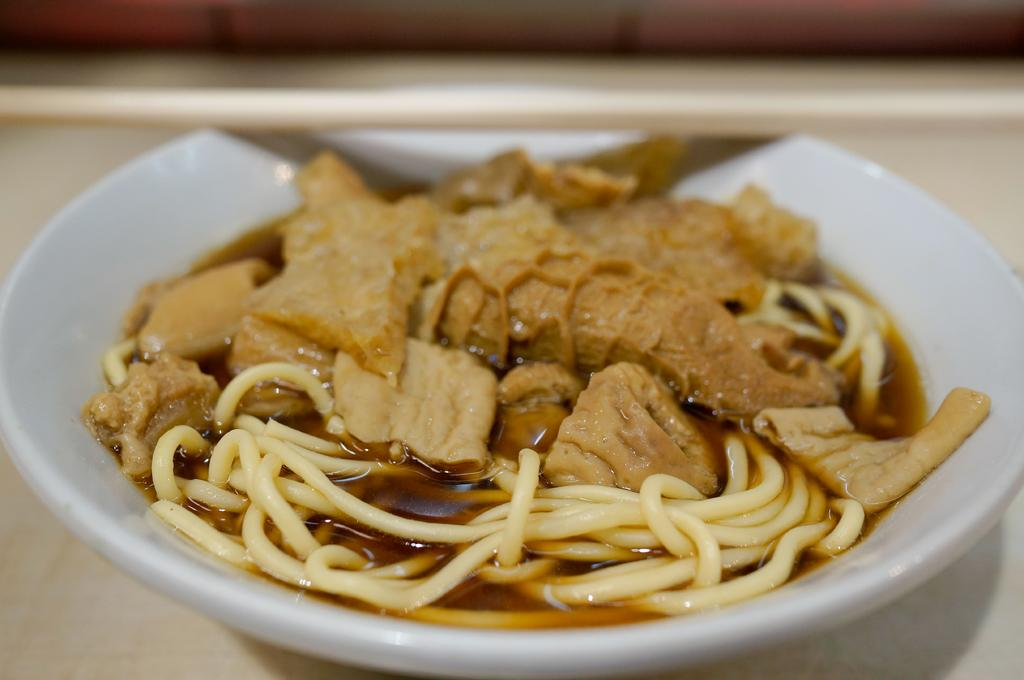What is the color of the bowl on the table in the image? The bowl on the table is white. What is inside the white bowl? The white bowl contains noodles, liquid, and other food items. What type of surface is the bowl placed on? The bowl is placed on a table. What can be seen on the wall in the image? There is a wooden wall visible in the image. How does the bowl manage to get the attention of the other food items in the image? The bowl does not have the ability to get the attention of other food items, as it is an inanimate object. 